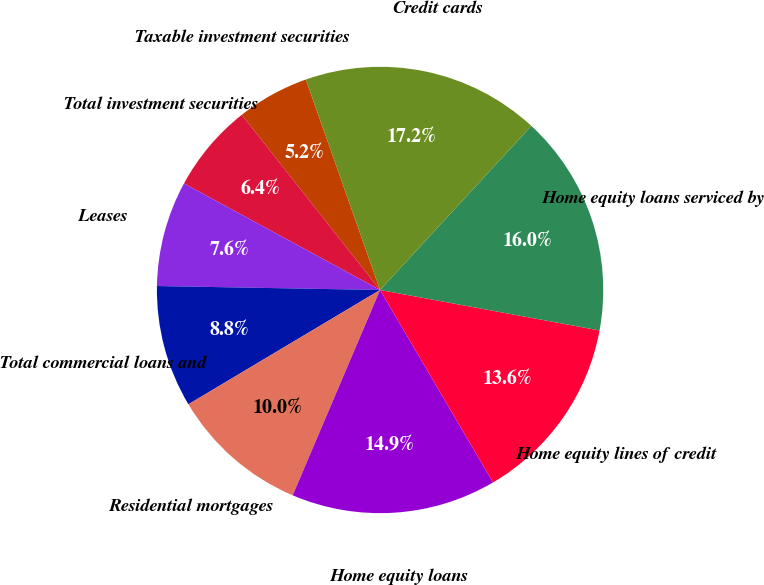<chart> <loc_0><loc_0><loc_500><loc_500><pie_chart><fcel>Taxable investment securities<fcel>Total investment securities<fcel>Leases<fcel>Total commercial loans and<fcel>Residential mortgages<fcel>Home equity loans<fcel>Home equity lines of credit<fcel>Home equity loans serviced by<fcel>Credit cards<nl><fcel>5.24%<fcel>6.44%<fcel>7.64%<fcel>8.84%<fcel>10.04%<fcel>14.85%<fcel>13.65%<fcel>16.05%<fcel>17.25%<nl></chart> 